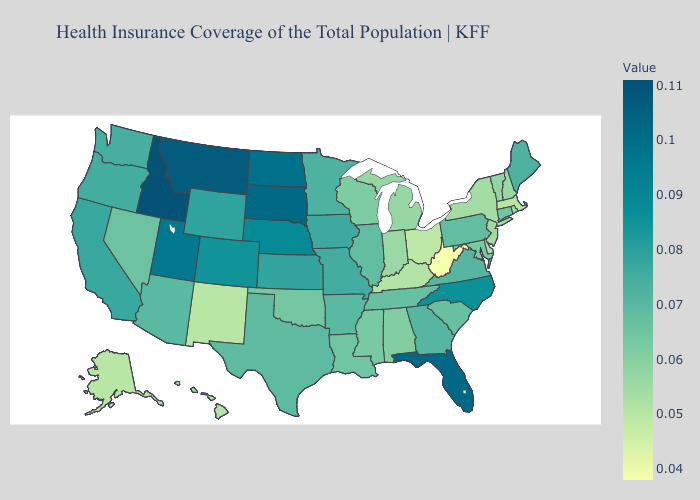Does New Jersey have a higher value than Georgia?
Write a very short answer. No. Does Ohio have the lowest value in the MidWest?
Give a very brief answer. Yes. Is the legend a continuous bar?
Concise answer only. Yes. 